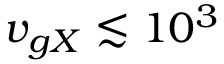Convert formula to latex. <formula><loc_0><loc_0><loc_500><loc_500>v _ { g X } \lesssim 1 0 ^ { 3 }</formula> 